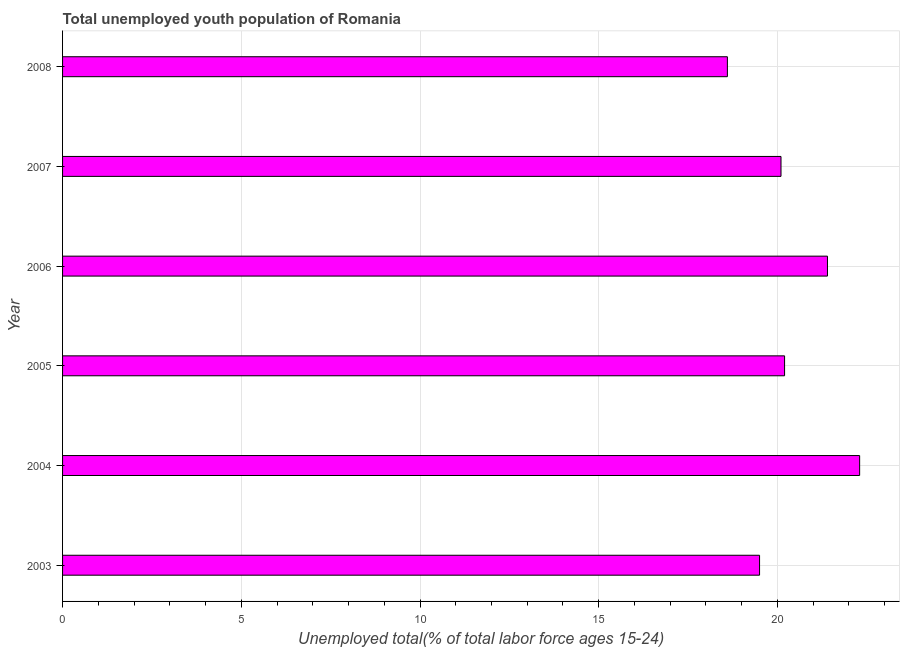Does the graph contain grids?
Offer a very short reply. Yes. What is the title of the graph?
Provide a short and direct response. Total unemployed youth population of Romania. What is the label or title of the X-axis?
Keep it short and to the point. Unemployed total(% of total labor force ages 15-24). What is the unemployed youth in 2003?
Offer a terse response. 19.5. Across all years, what is the maximum unemployed youth?
Offer a terse response. 22.3. Across all years, what is the minimum unemployed youth?
Your response must be concise. 18.6. In which year was the unemployed youth minimum?
Your response must be concise. 2008. What is the sum of the unemployed youth?
Offer a terse response. 122.1. What is the difference between the unemployed youth in 2003 and 2008?
Ensure brevity in your answer.  0.9. What is the average unemployed youth per year?
Your response must be concise. 20.35. What is the median unemployed youth?
Give a very brief answer. 20.15. In how many years, is the unemployed youth greater than 2 %?
Provide a succinct answer. 6. What is the ratio of the unemployed youth in 2004 to that in 2007?
Keep it short and to the point. 1.11. Is the difference between the unemployed youth in 2005 and 2008 greater than the difference between any two years?
Provide a succinct answer. No. Is the sum of the unemployed youth in 2004 and 2005 greater than the maximum unemployed youth across all years?
Your response must be concise. Yes. What is the difference between the highest and the lowest unemployed youth?
Provide a short and direct response. 3.7. Are the values on the major ticks of X-axis written in scientific E-notation?
Offer a very short reply. No. What is the Unemployed total(% of total labor force ages 15-24) of 2003?
Make the answer very short. 19.5. What is the Unemployed total(% of total labor force ages 15-24) of 2004?
Your answer should be compact. 22.3. What is the Unemployed total(% of total labor force ages 15-24) in 2005?
Provide a short and direct response. 20.2. What is the Unemployed total(% of total labor force ages 15-24) in 2006?
Keep it short and to the point. 21.4. What is the Unemployed total(% of total labor force ages 15-24) of 2007?
Keep it short and to the point. 20.1. What is the Unemployed total(% of total labor force ages 15-24) in 2008?
Provide a succinct answer. 18.6. What is the difference between the Unemployed total(% of total labor force ages 15-24) in 2003 and 2008?
Give a very brief answer. 0.9. What is the difference between the Unemployed total(% of total labor force ages 15-24) in 2004 and 2006?
Give a very brief answer. 0.9. What is the difference between the Unemployed total(% of total labor force ages 15-24) in 2004 and 2008?
Provide a succinct answer. 3.7. What is the difference between the Unemployed total(% of total labor force ages 15-24) in 2005 and 2008?
Your response must be concise. 1.6. What is the difference between the Unemployed total(% of total labor force ages 15-24) in 2006 and 2007?
Your answer should be compact. 1.3. What is the difference between the Unemployed total(% of total labor force ages 15-24) in 2006 and 2008?
Provide a short and direct response. 2.8. What is the ratio of the Unemployed total(% of total labor force ages 15-24) in 2003 to that in 2004?
Give a very brief answer. 0.87. What is the ratio of the Unemployed total(% of total labor force ages 15-24) in 2003 to that in 2006?
Make the answer very short. 0.91. What is the ratio of the Unemployed total(% of total labor force ages 15-24) in 2003 to that in 2008?
Offer a terse response. 1.05. What is the ratio of the Unemployed total(% of total labor force ages 15-24) in 2004 to that in 2005?
Keep it short and to the point. 1.1. What is the ratio of the Unemployed total(% of total labor force ages 15-24) in 2004 to that in 2006?
Provide a short and direct response. 1.04. What is the ratio of the Unemployed total(% of total labor force ages 15-24) in 2004 to that in 2007?
Your response must be concise. 1.11. What is the ratio of the Unemployed total(% of total labor force ages 15-24) in 2004 to that in 2008?
Your response must be concise. 1.2. What is the ratio of the Unemployed total(% of total labor force ages 15-24) in 2005 to that in 2006?
Keep it short and to the point. 0.94. What is the ratio of the Unemployed total(% of total labor force ages 15-24) in 2005 to that in 2008?
Make the answer very short. 1.09. What is the ratio of the Unemployed total(% of total labor force ages 15-24) in 2006 to that in 2007?
Your response must be concise. 1.06. What is the ratio of the Unemployed total(% of total labor force ages 15-24) in 2006 to that in 2008?
Keep it short and to the point. 1.15. What is the ratio of the Unemployed total(% of total labor force ages 15-24) in 2007 to that in 2008?
Offer a very short reply. 1.08. 